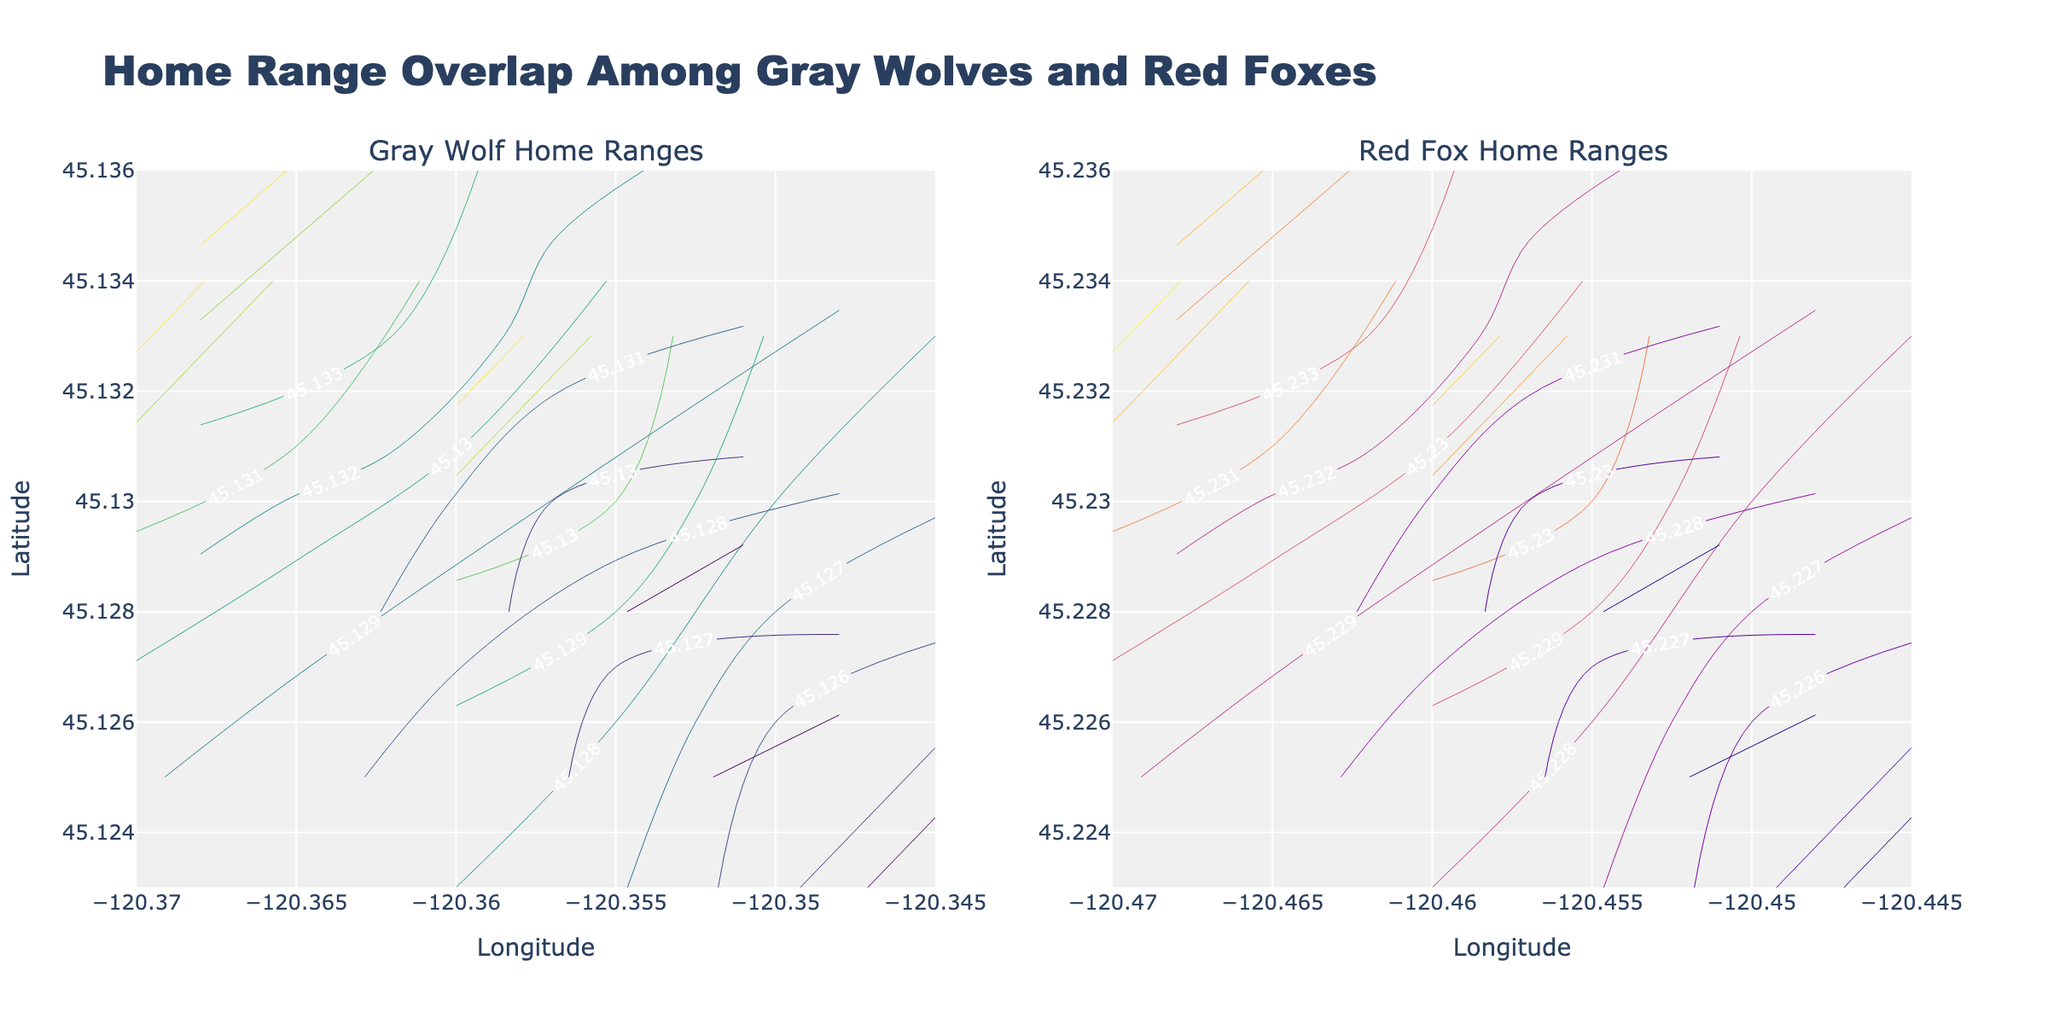How many animals are tracked in the Gray Wolf subplot? To determine the number of tracked animals in the Gray Wolf subplot, observe the legend corresponding to this subplot. Count the unique Animal IDs listed in the legend.
Answer: 3 What are the colors used for the contours in the Red Fox subplot? Examine the subplot for Red Foxes, specifically the lines representing latitudinal gradients. Identify the range of colors used for these contours.
Answer: Plasma color scale Which species has a larger geographical spread in terms of their home range, Gray Wolf or Red Fox? Compare the latitude and longitude ranges of the Gray Wolf and Red Fox subplots. Determine which subplot covers a broader geographical area by observing the span of the axis values.
Answer: Red Fox Do all Gray Wolves exhibit overlapping home ranges? Inspect the contour lines of the Gray Wolf subplot. Look for intersections or very close lines between different wolves to infer if there is an overlap in the areas they occupy.
Answer: Yes How do the GPS coordinates of Wolf_A change over time? Trace the contour lines corresponding to Wolf_A in the Gray Wolf subplot. Follow the points from the earliest timestamp to the latest and observe the changes in latitude and longitude values.
Answer: Latitude increases, Longitude decreases What is the title of the overall figure? Read the main title displayed at the top of the figure. This title provides a summary of what the figure represents.
Answer: "Home Range Overlap Among Gray Wolves and Red Foxes" Are there any foxes with non-overlapping home ranges? Examine the Red Fox subplot and look at whether the contour lines of each individual fox avoid intersecting with those of other foxes.
Answer: No What is the longitude range covered by the Gray Wolves? Observe the x-axis of the Gray Wolf subplot, noting the minimum and maximum longitude values displayed.
Answer: -120.370 to -120.345 Which animal, Wolf_B or Fox_A, travels the farthest within the given timeframe? Compare the contour span for Wolf_B and Fox_A by looking at how much the latitude and longitude values change from their starting points to their ending points within each subplot.
Answer: Fox_A How many unique timestamps were used for each animal? Observe the contour lines for any animal in either subplot. Notice the number of distinct labeled points along each contour, which correspond to the unique timestamps.
Answer: 4 